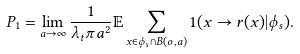Convert formula to latex. <formula><loc_0><loc_0><loc_500><loc_500>P _ { 1 } = \lim _ { a \rightarrow \infty } \frac { 1 } { \lambda _ { t } \pi a ^ { 2 } } \mathbb { E } \sum _ { x \in \phi _ { s } \cap B ( o , a ) } 1 ( x \rightarrow r ( x ) | \phi _ { s } ) .</formula> 